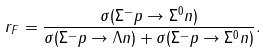Convert formula to latex. <formula><loc_0><loc_0><loc_500><loc_500>r _ { F } = \frac { \sigma ( \Sigma ^ { - } p \rightarrow \Sigma ^ { 0 } n ) } { \sigma ( \Sigma ^ { - } p \rightarrow \Lambda n ) + \sigma ( \Sigma ^ { - } p \rightarrow \Sigma ^ { 0 } n ) } .</formula> 